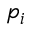<formula> <loc_0><loc_0><loc_500><loc_500>p _ { i }</formula> 